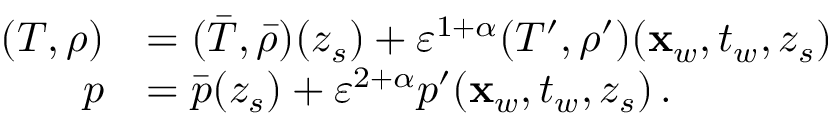<formula> <loc_0><loc_0><loc_500><loc_500>\begin{array} { r l } { ( T , \rho ) } & { = ( \bar { T } , \bar { \rho } ) ( z _ { s } ) + { \varepsilon } ^ { 1 + \alpha } ( T ^ { \prime } , \rho ^ { \prime } ) ( x _ { w } , t _ { w } , z _ { s } ) } \\ { p } & { = \bar { p } ( z _ { s } ) + { \varepsilon } ^ { 2 + \alpha } p ^ { \prime } ( x _ { w } , t _ { w } , z _ { s } ) \, . } \end{array}</formula> 